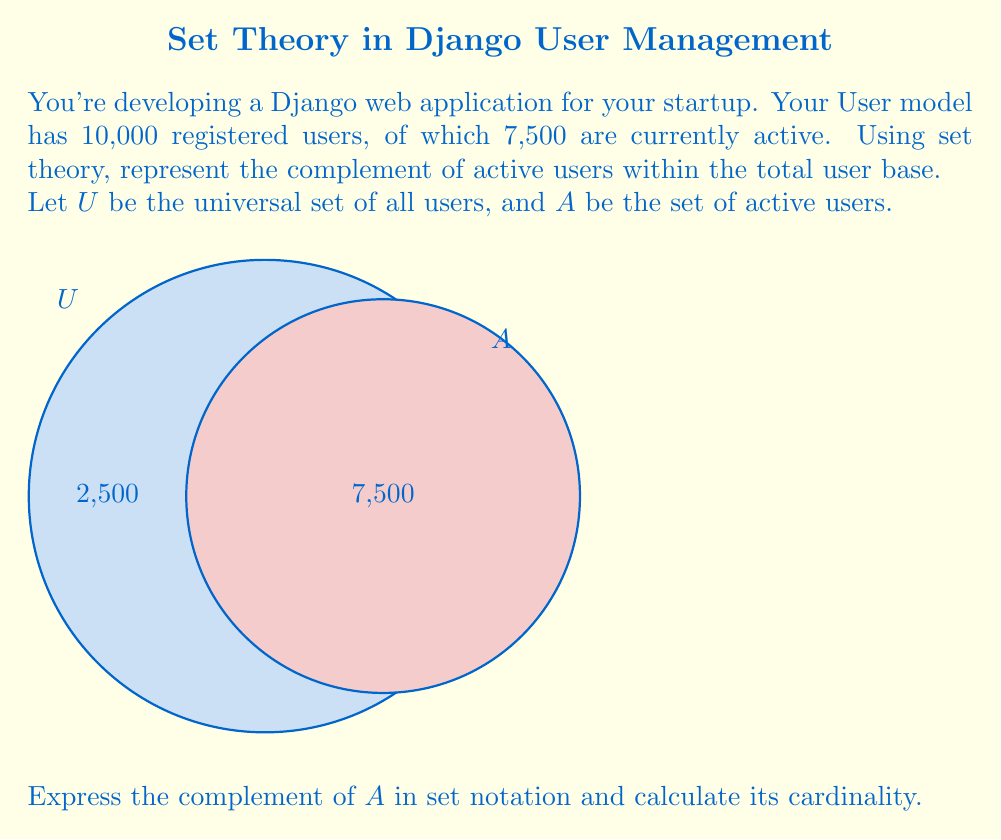Can you answer this question? Let's approach this step-by-step:

1) Define the sets:
   $U$ = Universal set (all users)
   $A$ = Set of active users

2) Given information:
   $|U| = 10,000$ (total number of users)
   $|A| = 7,500$ (number of active users)

3) The complement of $A$, denoted as $A^c$, represents all elements in $U$ that are not in $A$. In this context, it's the set of inactive users.

4) Set notation for the complement:
   $A^c = U \setminus A$ (read as "U minus A")

5) To find the cardinality of $A^c$:
   $|A^c| = |U| - |A|$
   $|A^c| = 10,000 - 7,500 = 2,500$

Therefore, the complement of $A$ (inactive users) contains 2,500 elements.
Answer: $A^c = U \setminus A$, $|A^c| = 2,500$ 